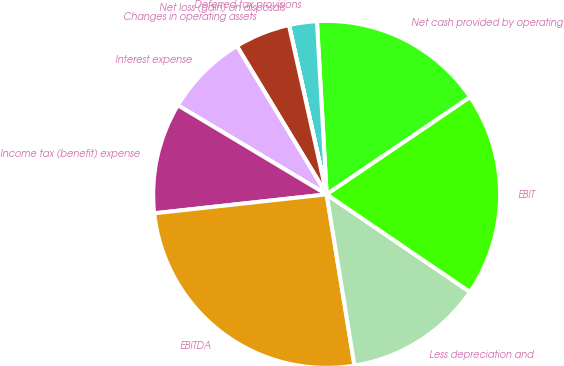Convert chart to OTSL. <chart><loc_0><loc_0><loc_500><loc_500><pie_chart><fcel>Net cash provided by operating<fcel>Deferred tax provisions<fcel>Net loss (gain) on disposals<fcel>Changes in operating assets<fcel>Interest expense<fcel>Income tax (benefit) expense<fcel>EBITDA<fcel>Less depreciation and<fcel>EBIT<nl><fcel>16.41%<fcel>2.59%<fcel>0.01%<fcel>5.17%<fcel>7.75%<fcel>10.33%<fcel>25.83%<fcel>12.92%<fcel>19.0%<nl></chart> 